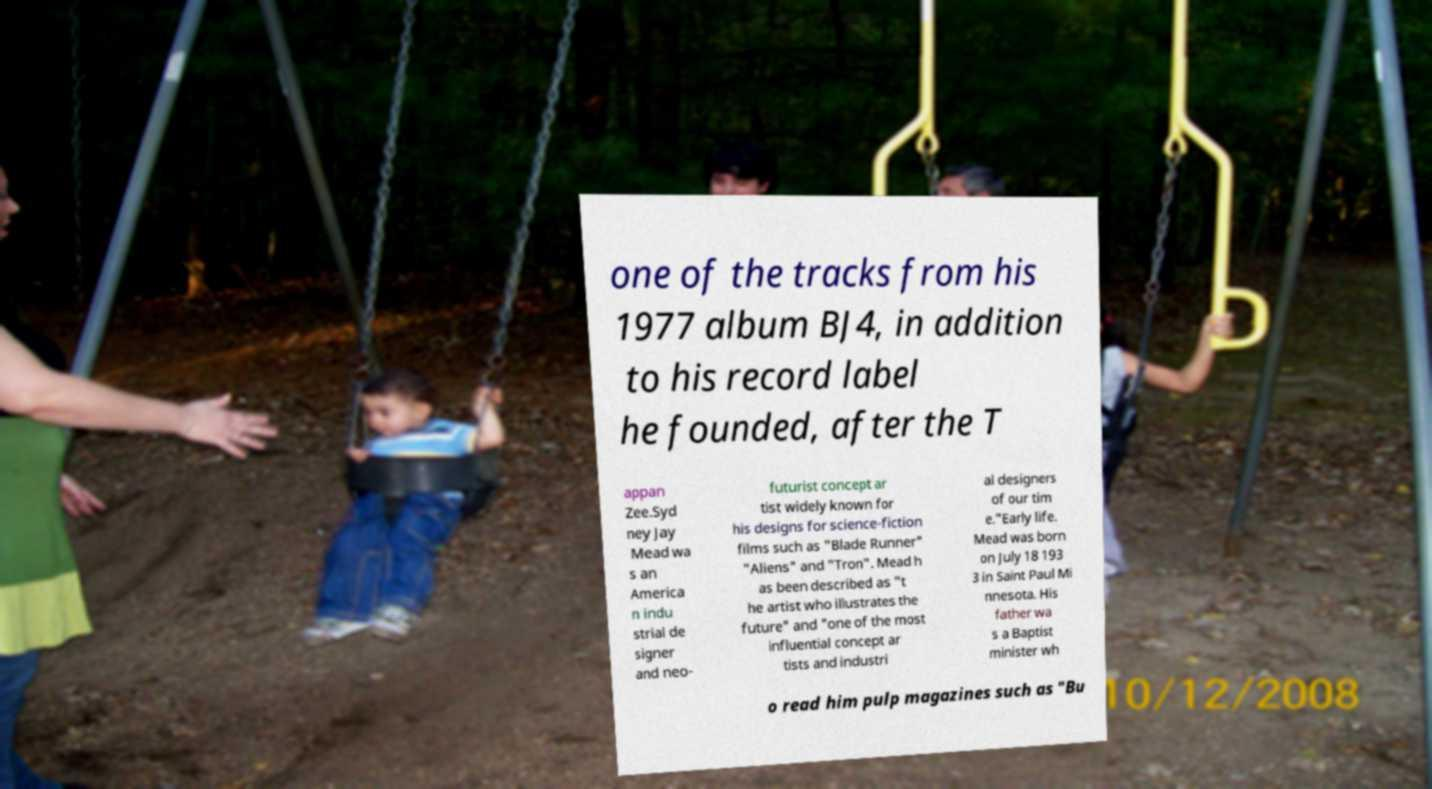Could you extract and type out the text from this image? one of the tracks from his 1977 album BJ4, in addition to his record label he founded, after the T appan Zee.Syd ney Jay Mead wa s an America n indu strial de signer and neo- futurist concept ar tist widely known for his designs for science-fiction films such as "Blade Runner" "Aliens" and "Tron". Mead h as been described as "t he artist who illustrates the future" and "one of the most influential concept ar tists and industri al designers of our tim e."Early life. Mead was born on July 18 193 3 in Saint Paul Mi nnesota. His father wa s a Baptist minister wh o read him pulp magazines such as "Bu 